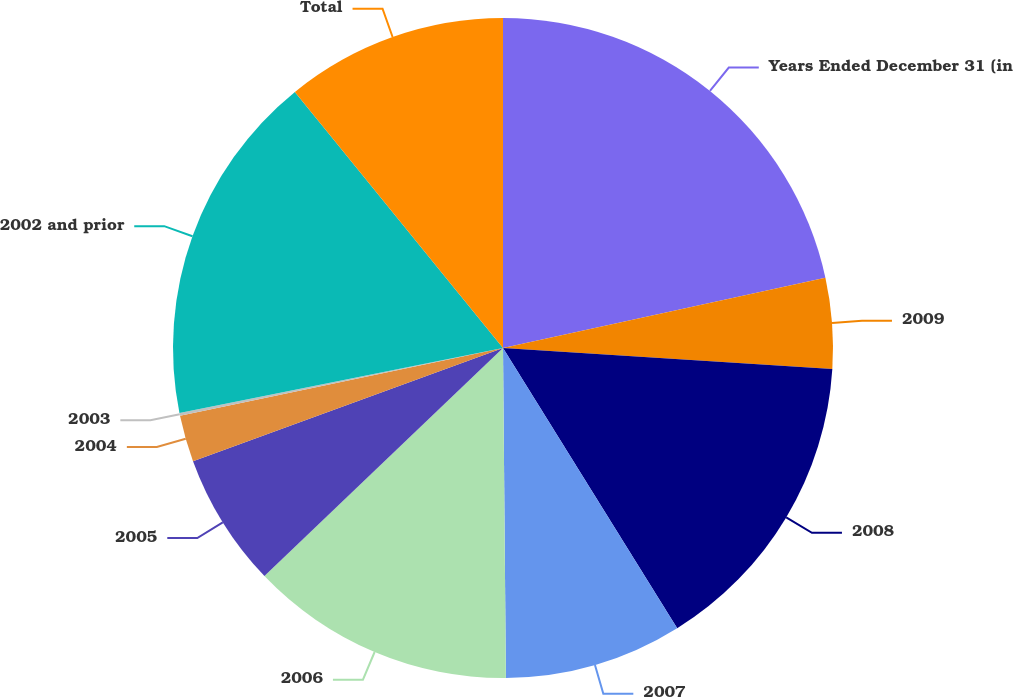Convert chart. <chart><loc_0><loc_0><loc_500><loc_500><pie_chart><fcel>Years Ended December 31 (in<fcel>2009<fcel>2008<fcel>2007<fcel>2006<fcel>2005<fcel>2004<fcel>2003<fcel>2002 and prior<fcel>Total<nl><fcel>21.58%<fcel>4.43%<fcel>15.14%<fcel>8.71%<fcel>13.0%<fcel>6.57%<fcel>2.28%<fcel>0.14%<fcel>17.29%<fcel>10.86%<nl></chart> 